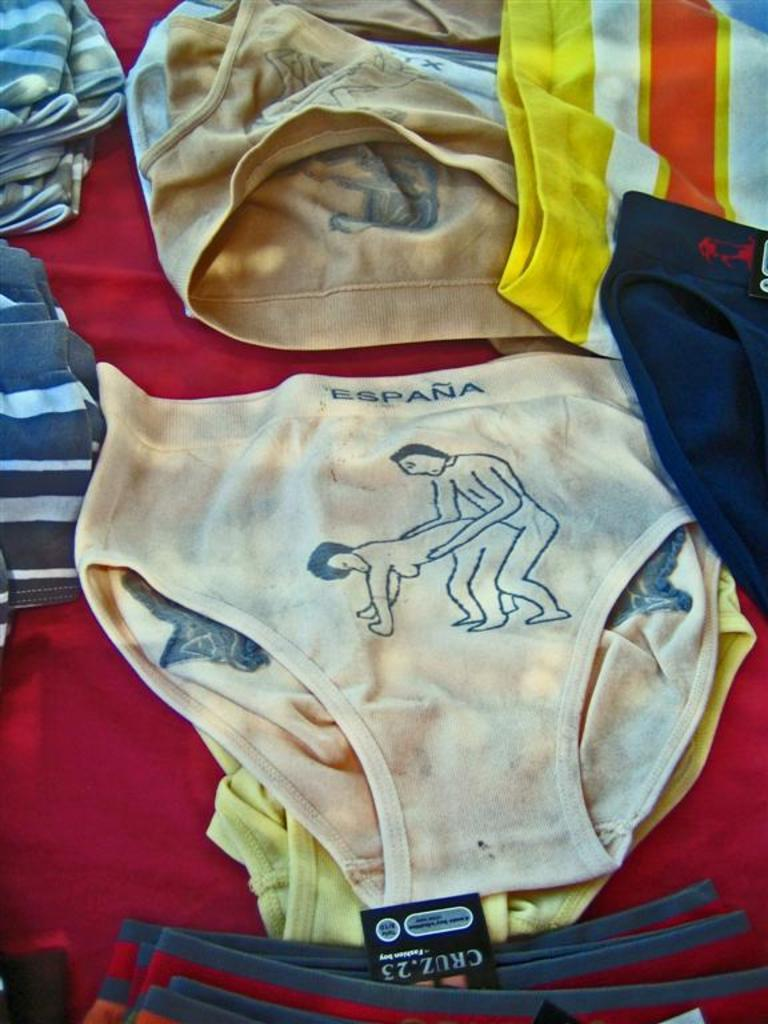<image>
Provide a brief description of the given image. A sexual scene is printed on a pair of Espana underwear. 